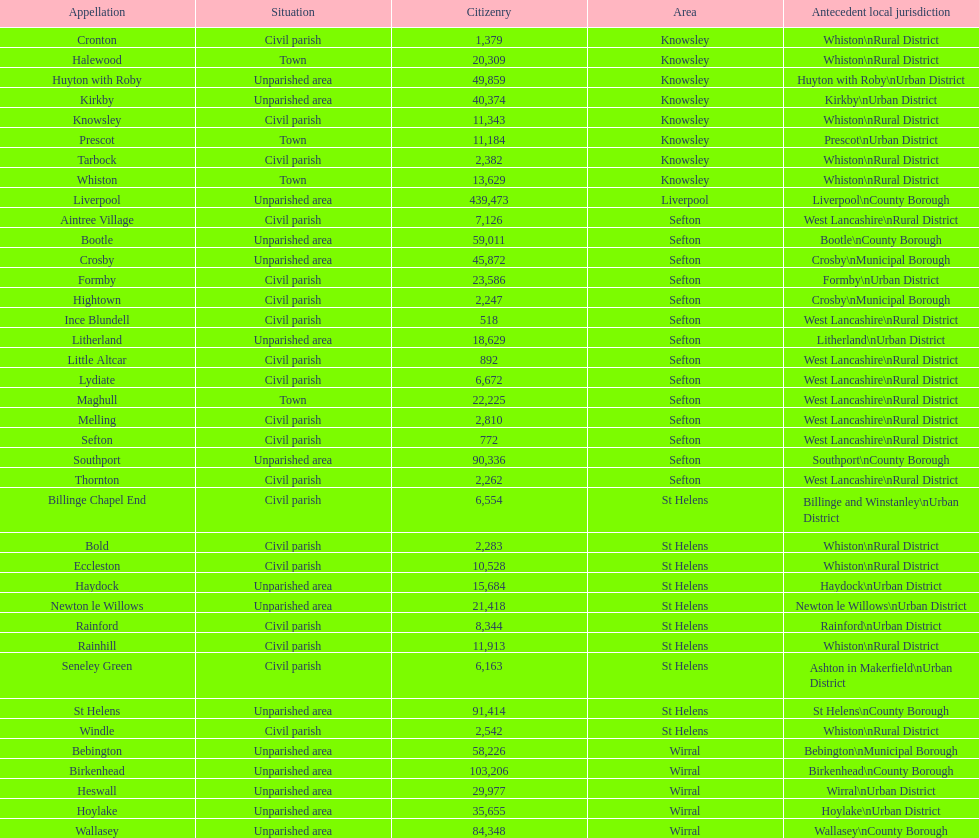Which area has the least number of residents? Ince Blundell. 